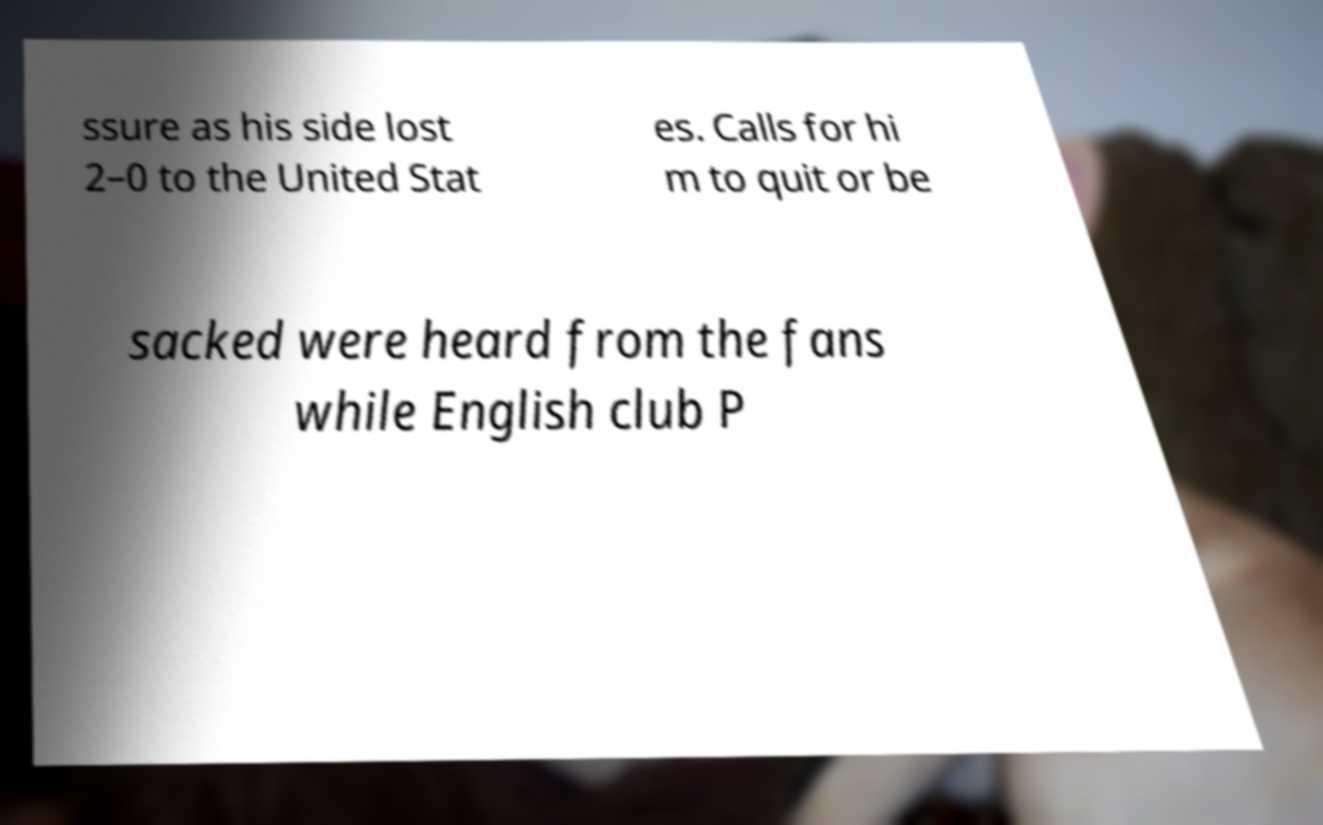I need the written content from this picture converted into text. Can you do that? ssure as his side lost 2–0 to the United Stat es. Calls for hi m to quit or be sacked were heard from the fans while English club P 